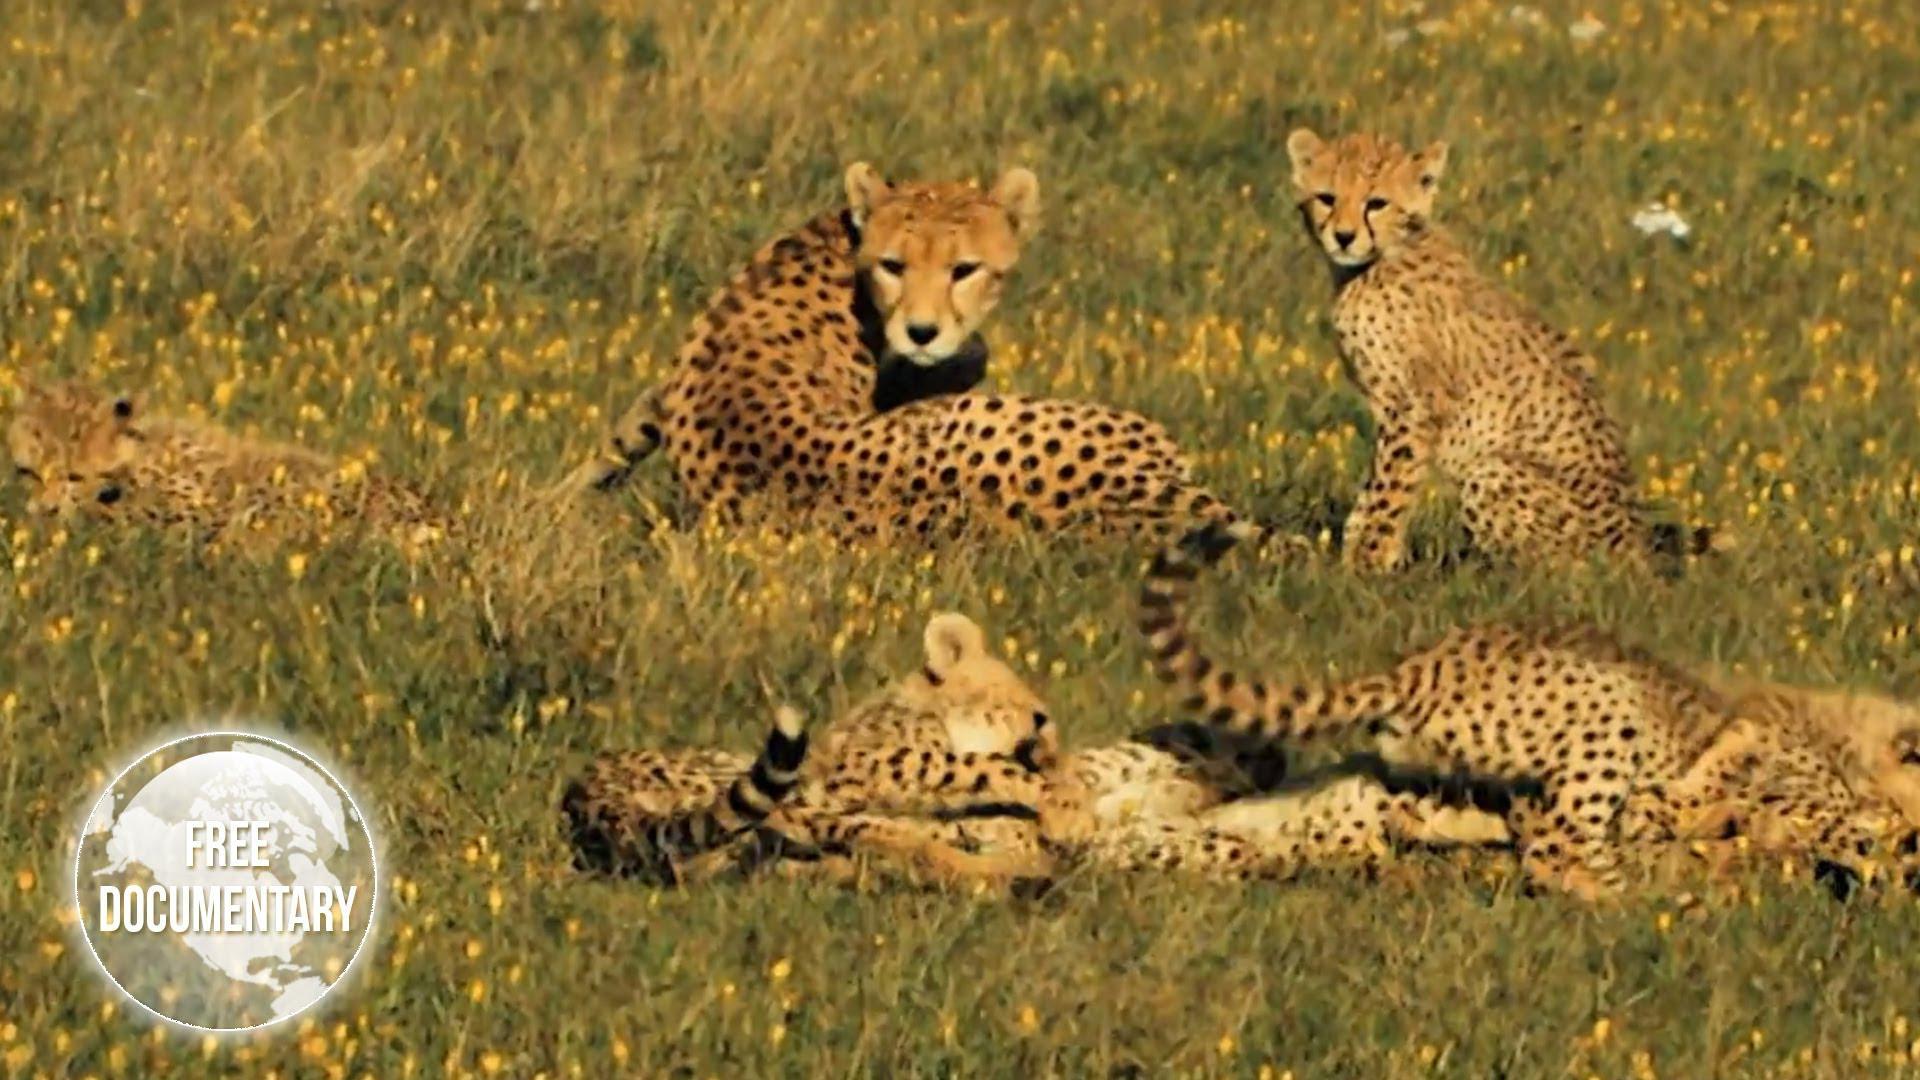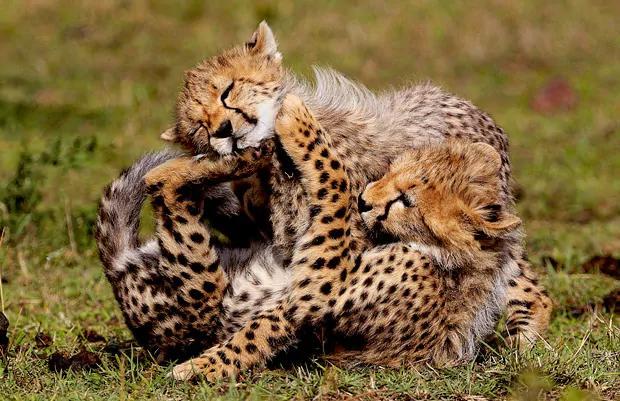The first image is the image on the left, the second image is the image on the right. Examine the images to the left and right. Is the description "One of the images features a young cat leaping into the air to pounce on another cat." accurate? Answer yes or no. No. 